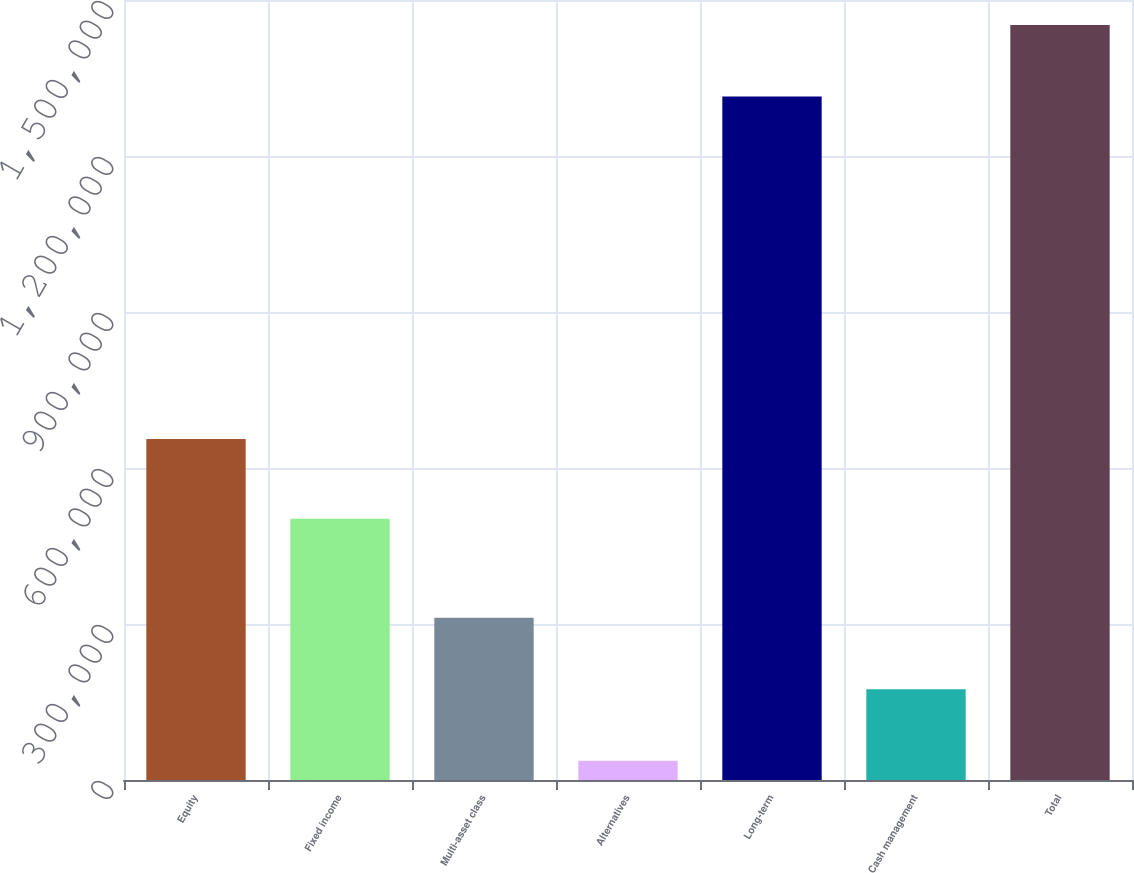Convert chart to OTSL. <chart><loc_0><loc_0><loc_500><loc_500><bar_chart><fcel>Equity<fcel>Fixed income<fcel>Multi-asset class<fcel>Alternatives<fcel>Long-term<fcel>Cash management<fcel>Total<nl><fcel>655985<fcel>502324<fcel>312142<fcel>36817<fcel>1.31448e+06<fcel>174479<fcel>1.45214e+06<nl></chart> 